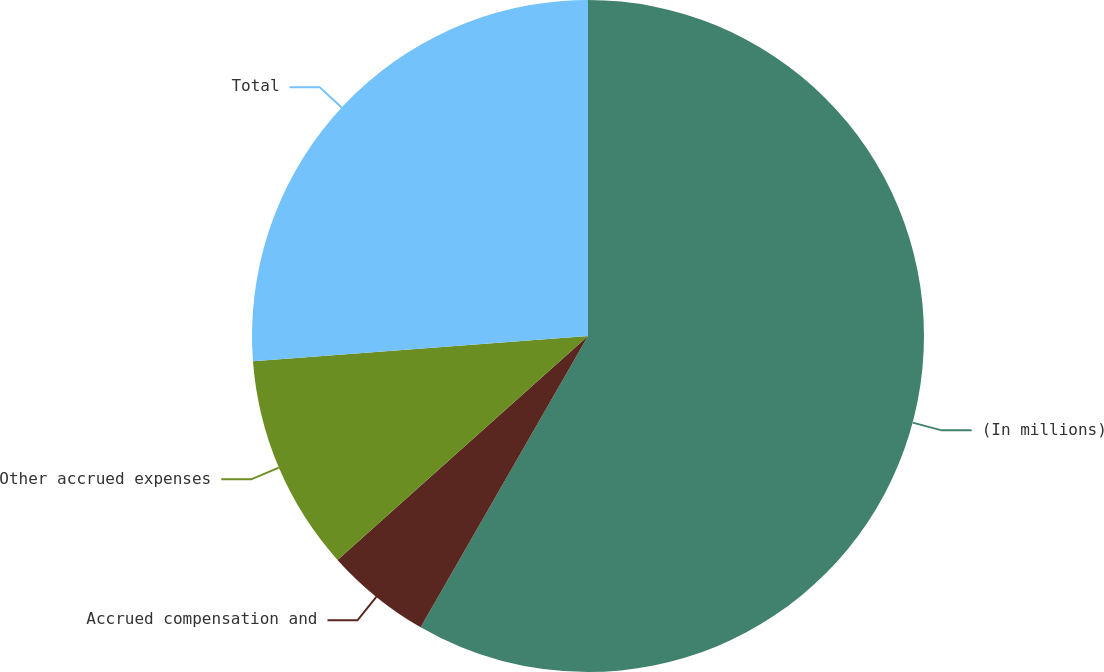<chart> <loc_0><loc_0><loc_500><loc_500><pie_chart><fcel>(In millions)<fcel>Accrued compensation and<fcel>Other accrued expenses<fcel>Total<nl><fcel>58.3%<fcel>5.09%<fcel>10.41%<fcel>26.2%<nl></chart> 